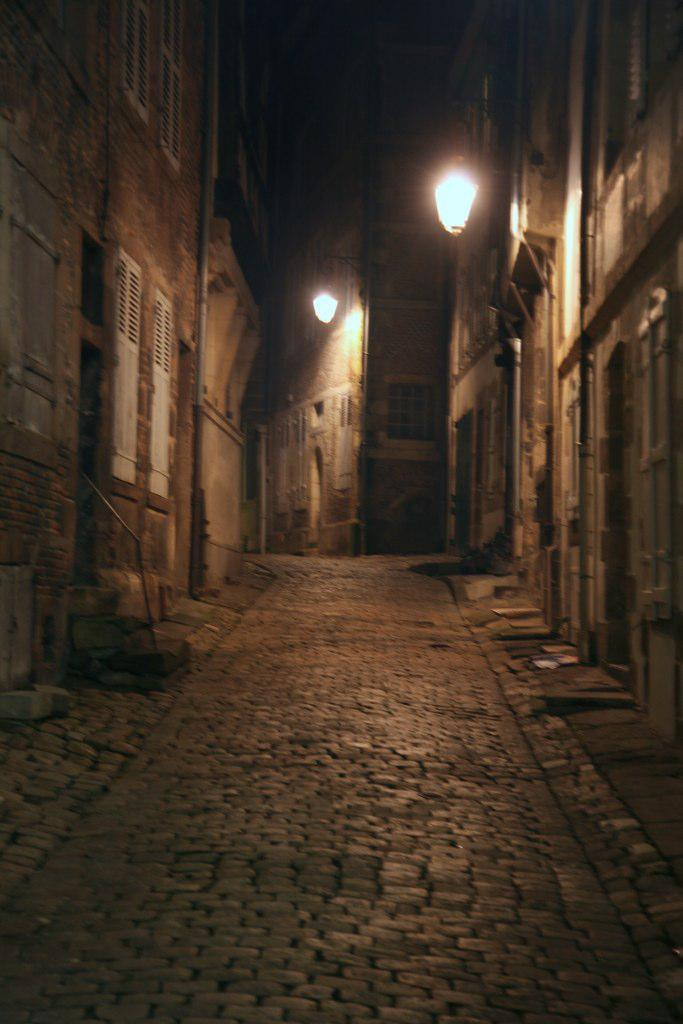What type of pathway is visible in the image? There is a road in the image. What structures can be seen alongside the road? There are buildings visible in the image. What type of illumination is present in the image? There are lights present in the image. What type of muscle can be seen flexing in the image? There is no muscle visible in the image; it features a road, buildings, and lights. 